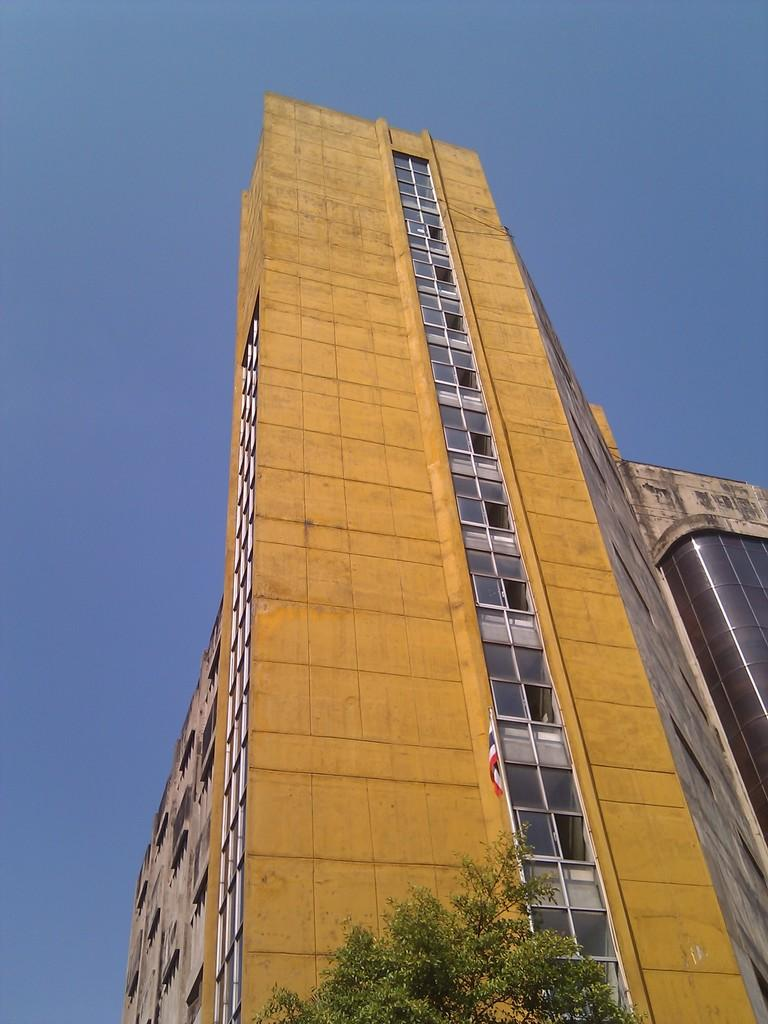What is located at the bottom of the image? There is a tree at the bottom of the image. What can be seen in the center of the image? There is a flag and a building with windows in the center of the image. What is the condition of the sky in the image? The sky is clear in the image. What is the weather like in the image? It is sunny in the image. What type of disease is affecting the tree at the bottom of the image? There is no indication of any disease affecting the tree in the image; it appears healthy. Can you tell me how many kettles are visible in the image? There are no kettles present in the image. 